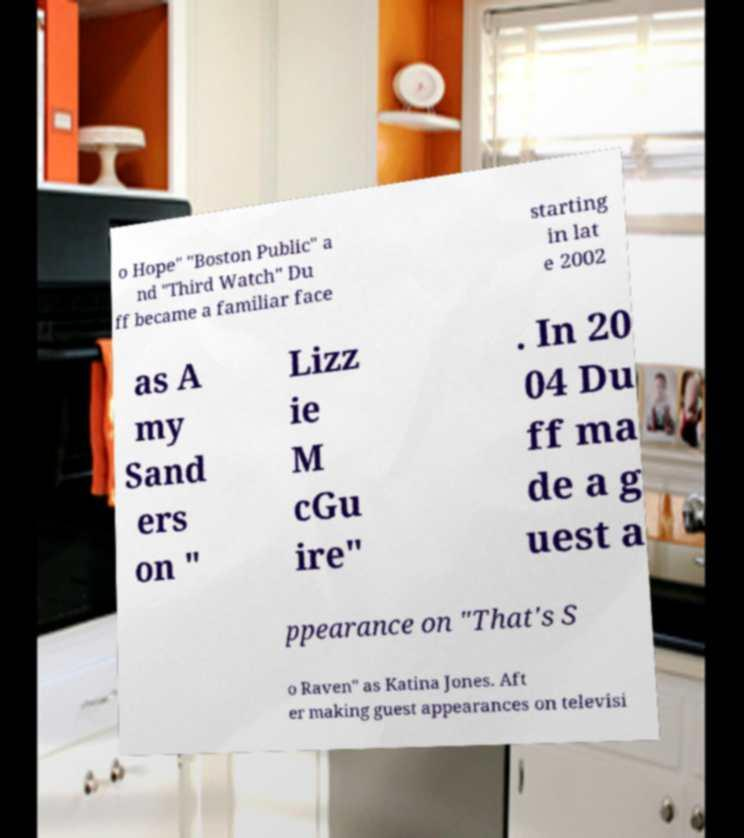Can you read and provide the text displayed in the image?This photo seems to have some interesting text. Can you extract and type it out for me? o Hope" "Boston Public" a nd "Third Watch" Du ff became a familiar face starting in lat e 2002 as A my Sand ers on " Lizz ie M cGu ire" . In 20 04 Du ff ma de a g uest a ppearance on "That's S o Raven" as Katina Jones. Aft er making guest appearances on televisi 